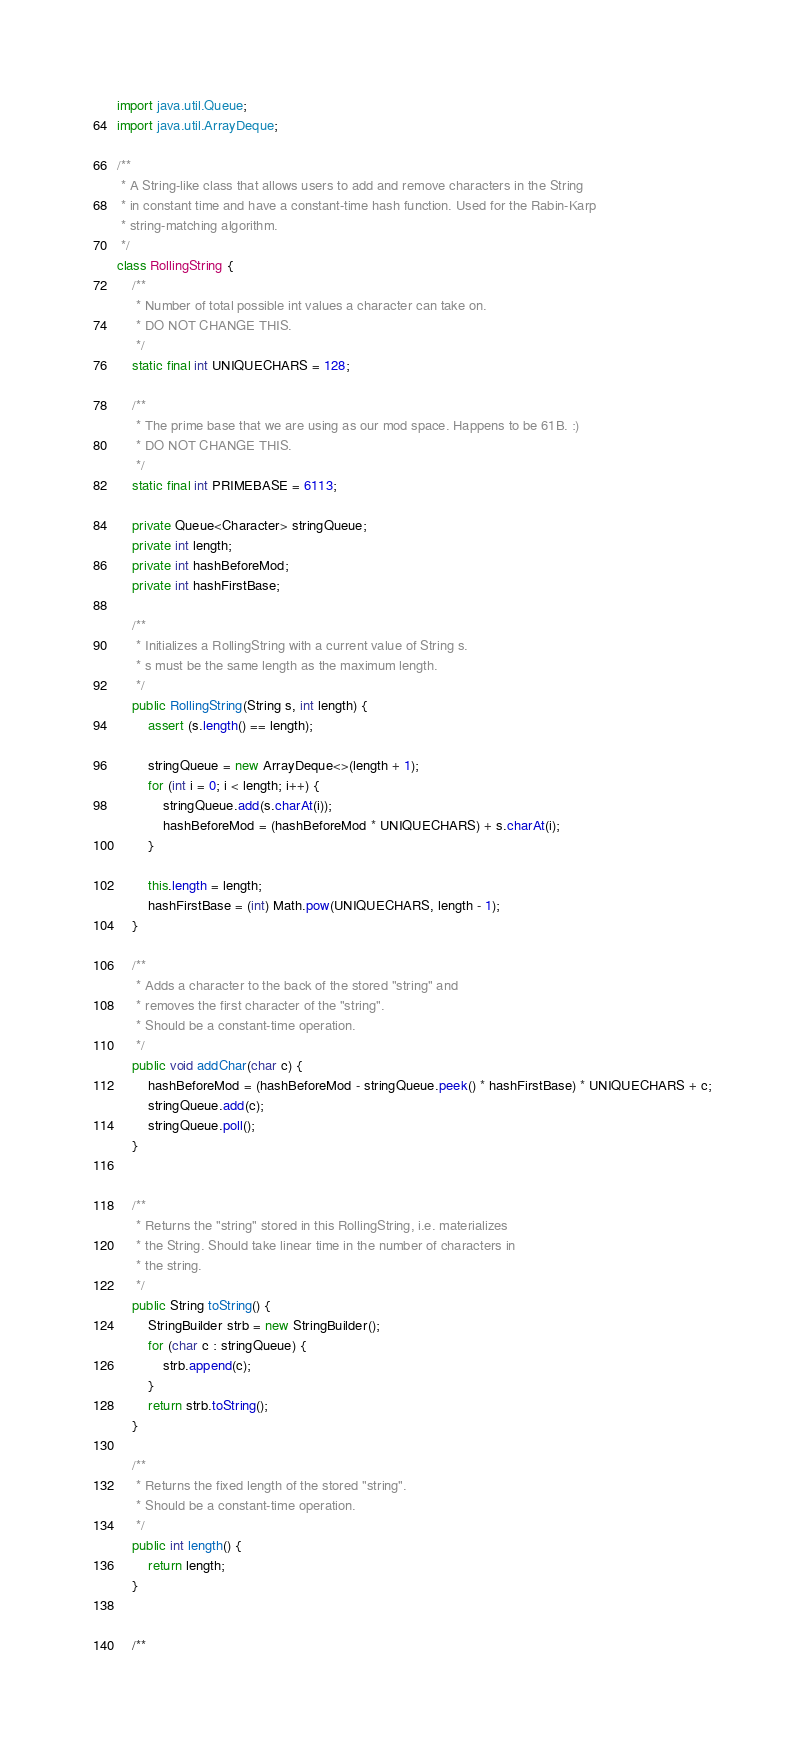Convert code to text. <code><loc_0><loc_0><loc_500><loc_500><_Java_>import java.util.Queue;
import java.util.ArrayDeque;

/**
 * A String-like class that allows users to add and remove characters in the String
 * in constant time and have a constant-time hash function. Used for the Rabin-Karp
 * string-matching algorithm.
 */
class RollingString {
    /**
     * Number of total possible int values a character can take on.
     * DO NOT CHANGE THIS.
     */
    static final int UNIQUECHARS = 128;

    /**
     * The prime base that we are using as our mod space. Happens to be 61B. :)
     * DO NOT CHANGE THIS.
     */
    static final int PRIMEBASE = 6113;

    private Queue<Character> stringQueue;
    private int length;
    private int hashBeforeMod;
    private int hashFirstBase;

    /**
     * Initializes a RollingString with a current value of String s.
     * s must be the same length as the maximum length.
     */
    public RollingString(String s, int length) {
        assert (s.length() == length);

        stringQueue = new ArrayDeque<>(length + 1);
        for (int i = 0; i < length; i++) {
            stringQueue.add(s.charAt(i));
            hashBeforeMod = (hashBeforeMod * UNIQUECHARS) + s.charAt(i);
        }

        this.length = length;
        hashFirstBase = (int) Math.pow(UNIQUECHARS, length - 1);
    }

    /**
     * Adds a character to the back of the stored "string" and
     * removes the first character of the "string".
     * Should be a constant-time operation.
     */
    public void addChar(char c) {
        hashBeforeMod = (hashBeforeMod - stringQueue.peek() * hashFirstBase) * UNIQUECHARS + c;
        stringQueue.add(c);
        stringQueue.poll();
    }


    /**
     * Returns the "string" stored in this RollingString, i.e. materializes
     * the String. Should take linear time in the number of characters in
     * the string.
     */
    public String toString() {
        StringBuilder strb = new StringBuilder();
        for (char c : stringQueue) {
            strb.append(c);
        }
        return strb.toString();
    }

    /**
     * Returns the fixed length of the stored "string".
     * Should be a constant-time operation.
     */
    public int length() {
        return length;
    }


    /**</code> 